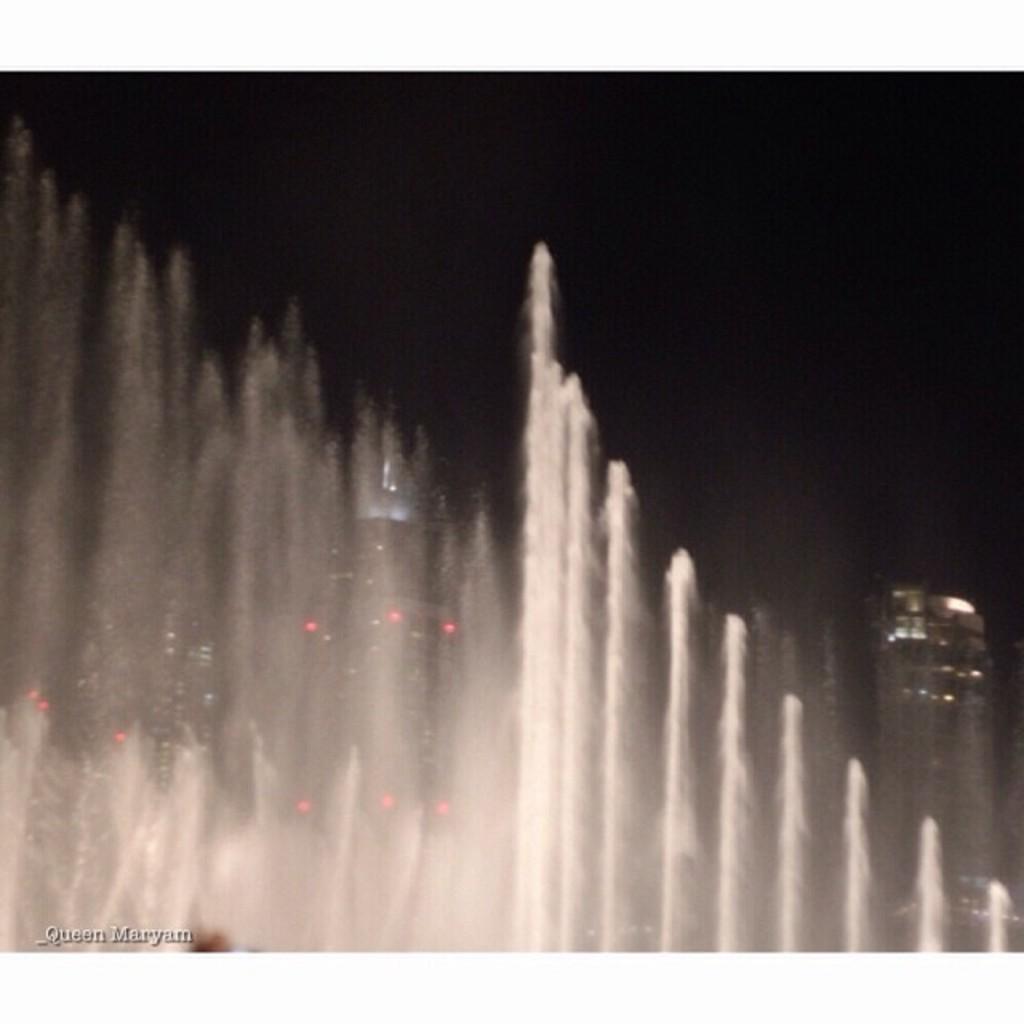How would you summarize this image in a sentence or two? In the front of the image there is a water-fountain. In the background of the image there are buildings and dark sky. At the bottom left side of the image there is a watermark. 